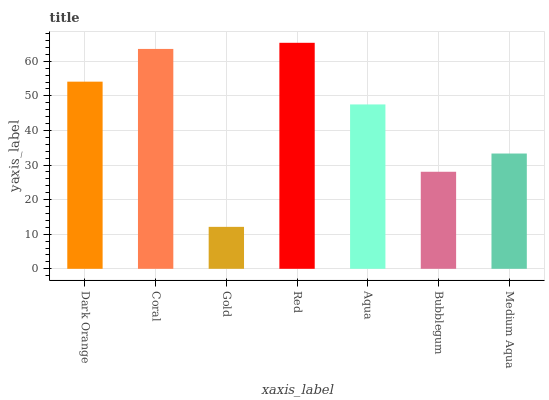Is Coral the minimum?
Answer yes or no. No. Is Coral the maximum?
Answer yes or no. No. Is Coral greater than Dark Orange?
Answer yes or no. Yes. Is Dark Orange less than Coral?
Answer yes or no. Yes. Is Dark Orange greater than Coral?
Answer yes or no. No. Is Coral less than Dark Orange?
Answer yes or no. No. Is Aqua the high median?
Answer yes or no. Yes. Is Aqua the low median?
Answer yes or no. Yes. Is Coral the high median?
Answer yes or no. No. Is Coral the low median?
Answer yes or no. No. 